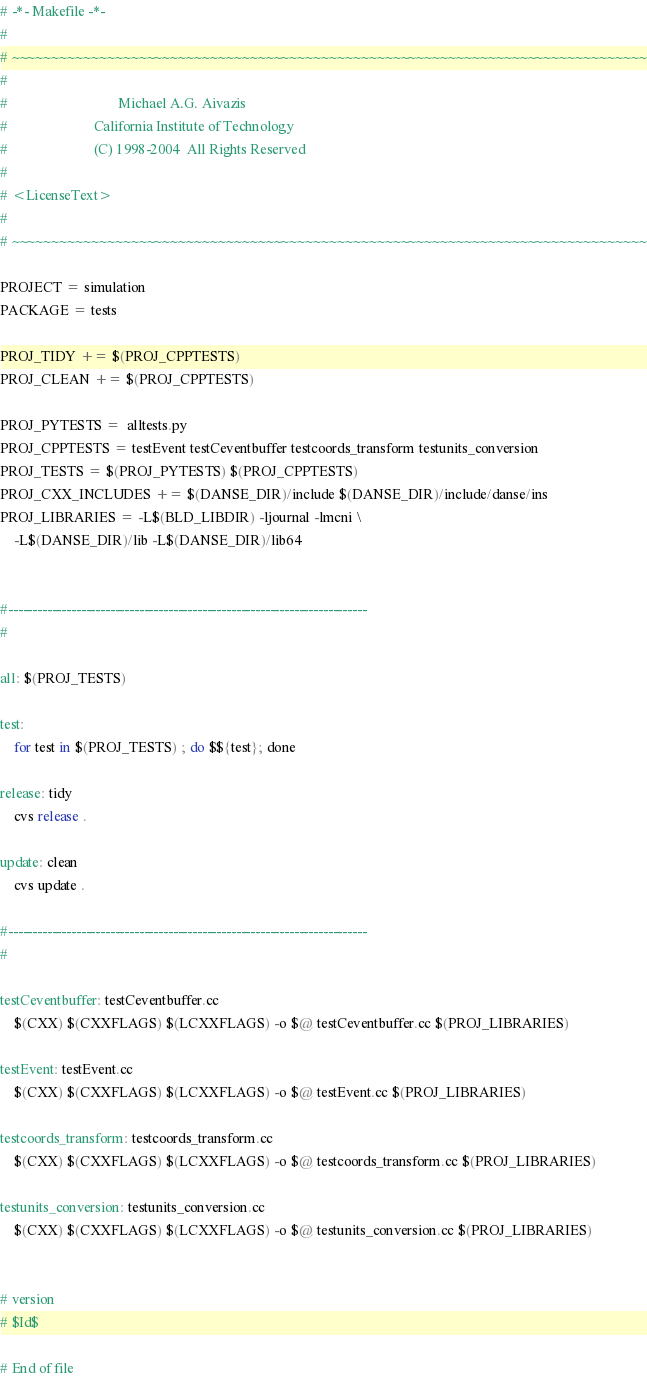Convert code to text. <code><loc_0><loc_0><loc_500><loc_500><_ObjectiveC_># -*- Makefile -*-
#
# ~~~~~~~~~~~~~~~~~~~~~~~~~~~~~~~~~~~~~~~~~~~~~~~~~~~~~~~~~~~~~~~~~~~~~~~~~~~~~~~~
#
#                               Michael A.G. Aivazis
#                        California Institute of Technology
#                        (C) 1998-2004  All Rights Reserved
#
# <LicenseText>
#
# ~~~~~~~~~~~~~~~~~~~~~~~~~~~~~~~~~~~~~~~~~~~~~~~~~~~~~~~~~~~~~~~~~~~~~~~~~~~~~~~~

PROJECT = simulation
PACKAGE = tests

PROJ_TIDY += $(PROJ_CPPTESTS)
PROJ_CLEAN += $(PROJ_CPPTESTS)

PROJ_PYTESTS =  alltests.py
PROJ_CPPTESTS = testEvent testCeventbuffer testcoords_transform testunits_conversion
PROJ_TESTS = $(PROJ_PYTESTS) $(PROJ_CPPTESTS)
PROJ_CXX_INCLUDES += $(DANSE_DIR)/include $(DANSE_DIR)/include/danse/ins
PROJ_LIBRARIES = -L$(BLD_LIBDIR) -ljournal -lmcni \
	-L$(DANSE_DIR)/lib -L$(DANSE_DIR)/lib64


#--------------------------------------------------------------------------
#

all: $(PROJ_TESTS)

test:
	for test in $(PROJ_TESTS) ; do $${test}; done

release: tidy
	cvs release .

update: clean
	cvs update .

#--------------------------------------------------------------------------
#

testCeventbuffer: testCeventbuffer.cc 
	$(CXX) $(CXXFLAGS) $(LCXXFLAGS) -o $@ testCeventbuffer.cc $(PROJ_LIBRARIES)

testEvent: testEvent.cc 
	$(CXX) $(CXXFLAGS) $(LCXXFLAGS) -o $@ testEvent.cc $(PROJ_LIBRARIES)

testcoords_transform: testcoords_transform.cc 
	$(CXX) $(CXXFLAGS) $(LCXXFLAGS) -o $@ testcoords_transform.cc $(PROJ_LIBRARIES)

testunits_conversion: testunits_conversion.cc 
	$(CXX) $(CXXFLAGS) $(LCXXFLAGS) -o $@ testunits_conversion.cc $(PROJ_LIBRARIES)


# version
# $Id$

# End of file
</code> 